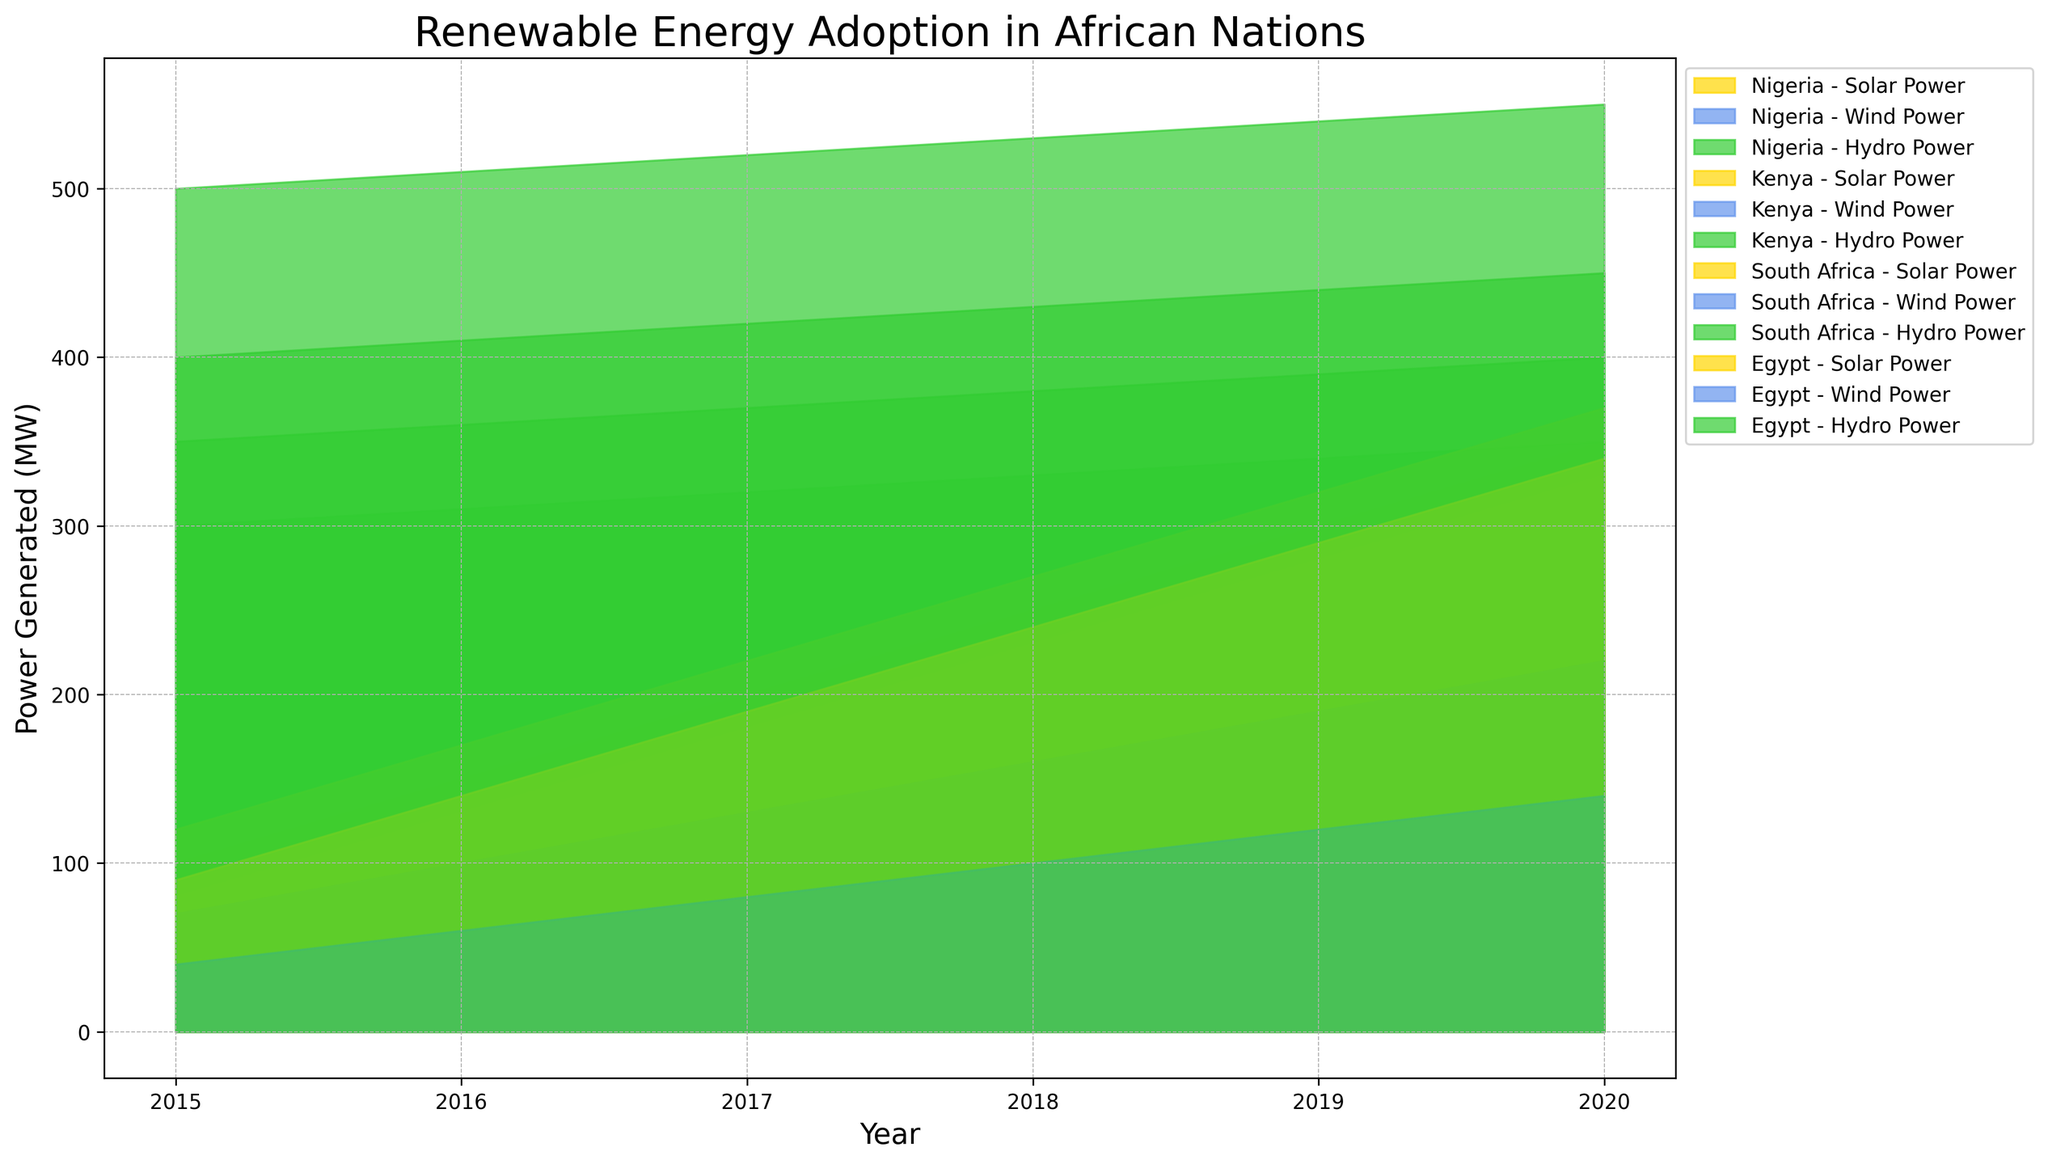What country had the highest solar power generation in 2020? By observing the visual data for 2020, the highest area representing solar power corresponds to South Africa.
Answer: South Africa Did hydro power generation increase or decrease in Nigeria from 2015 to 2020? Comparing the height of the hydro power area between 2015 and 2020 for Nigeria, there is an increase.
Answer: Increase Which type of renewable energy saw the greatest overall increase in Kenya between 2015 and 2020? Looking at the areas representing solar, wind, and hydro power in Kenya from 2015 to 2020, solar and wind power increase seen visually. Solar power had a noticeable larger increase.
Answer: Solar Power What was the combined solar power generation of Kenya and Egypt in 2018? From the visual data, the height of the solar power areas for Kenya in 2018 is 230, and Egypt is 240. Adding them together gives 230 + 240 = 470 MW.
Answer: 470 MW Was there a year where Egypt’s solar power was higher than its hydro power? By comparing the areas of solar and hydro power in Egypt across all years, the hydro power area is always larger than the solar power area.
Answer: No Compare the wind power generation of South Africa and Nigeria in 2017. The areas for wind power generation in 2017 show South Africa's area height is 130, and Nigeria's is 100. South Africa's is higher.
Answer: South Africa Is there any country where wind power overtook solar power in any year? By examining the height of the wind and solar power areas for each country and year, no country has a higher wind than solar at any point.
Answer: No How did the total renewable energy generation of Nigeria change from 2015 to 2020? Summing the heights of solar, wind, and hydro power areas for Nigeria in 2015 and 2020, the values are (100 + 50 + 300) for 2015 and (350 + 175 + 350) for 2020. The total increases from 450 to 875 MW.
Answer: Increase 